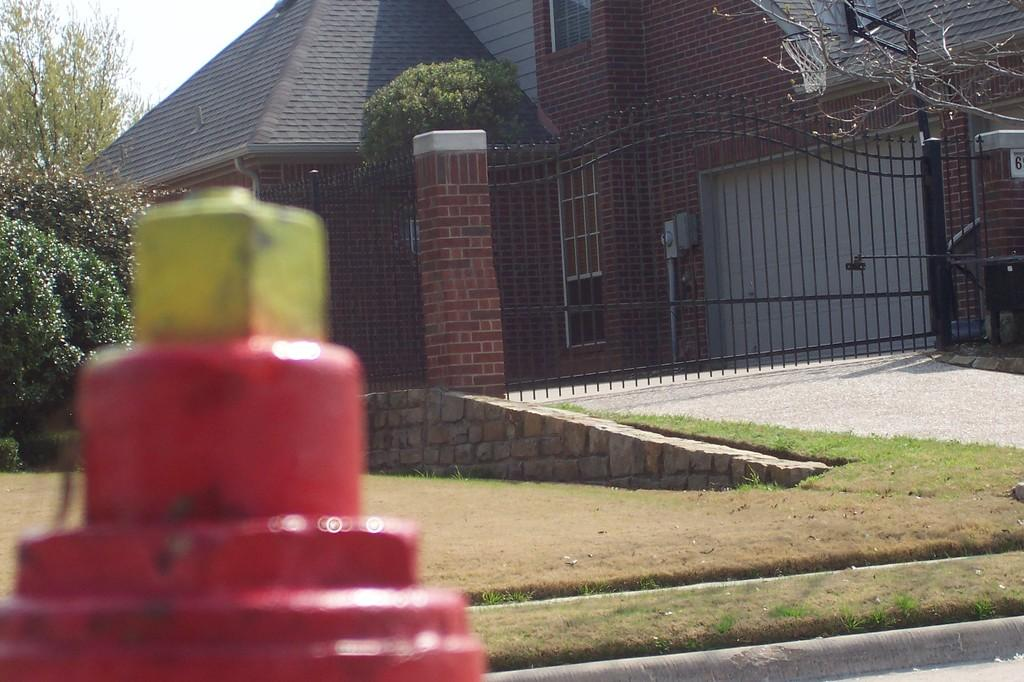What object is located in the foreground of the image? There is a fire hydrant-like object in the foreground of the image. What structures can be seen in the background of the image? There are buildings and a gate in the background of the image. What type of vegetation is visible in the background of the image? There are trees in the background of the image. What architectural feature is present in the background of the image? There is a ramp in the background of the image. What type of ground cover is visible in the background of the image? There is grass in the background of the image. What part of the natural environment is visible in the background of the image? The sky is visible in the background of the image. What type of pancake is being served on the ramp in the image? There is no pancake present in the image, and the ramp is not associated with serving food. What is the reason for the knot in the tree in the image? There is no knot in any of the trees depicted in the image. 